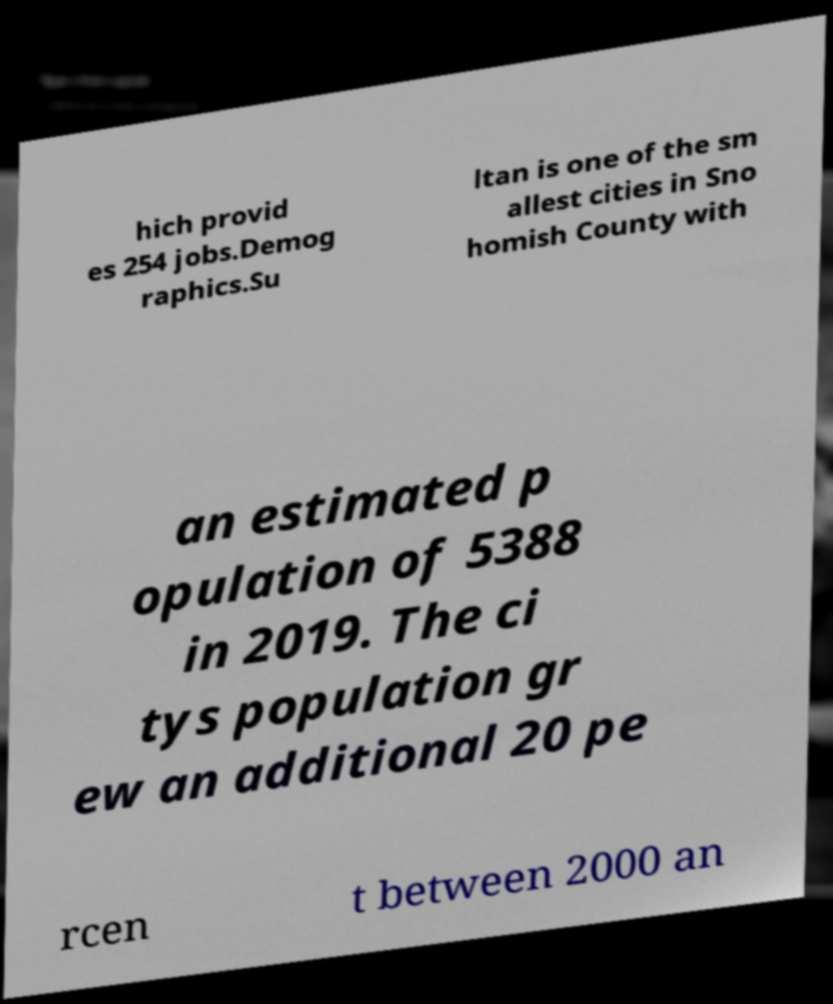Could you assist in decoding the text presented in this image and type it out clearly? hich provid es 254 jobs.Demog raphics.Su ltan is one of the sm allest cities in Sno homish County with an estimated p opulation of 5388 in 2019. The ci tys population gr ew an additional 20 pe rcen t between 2000 an 